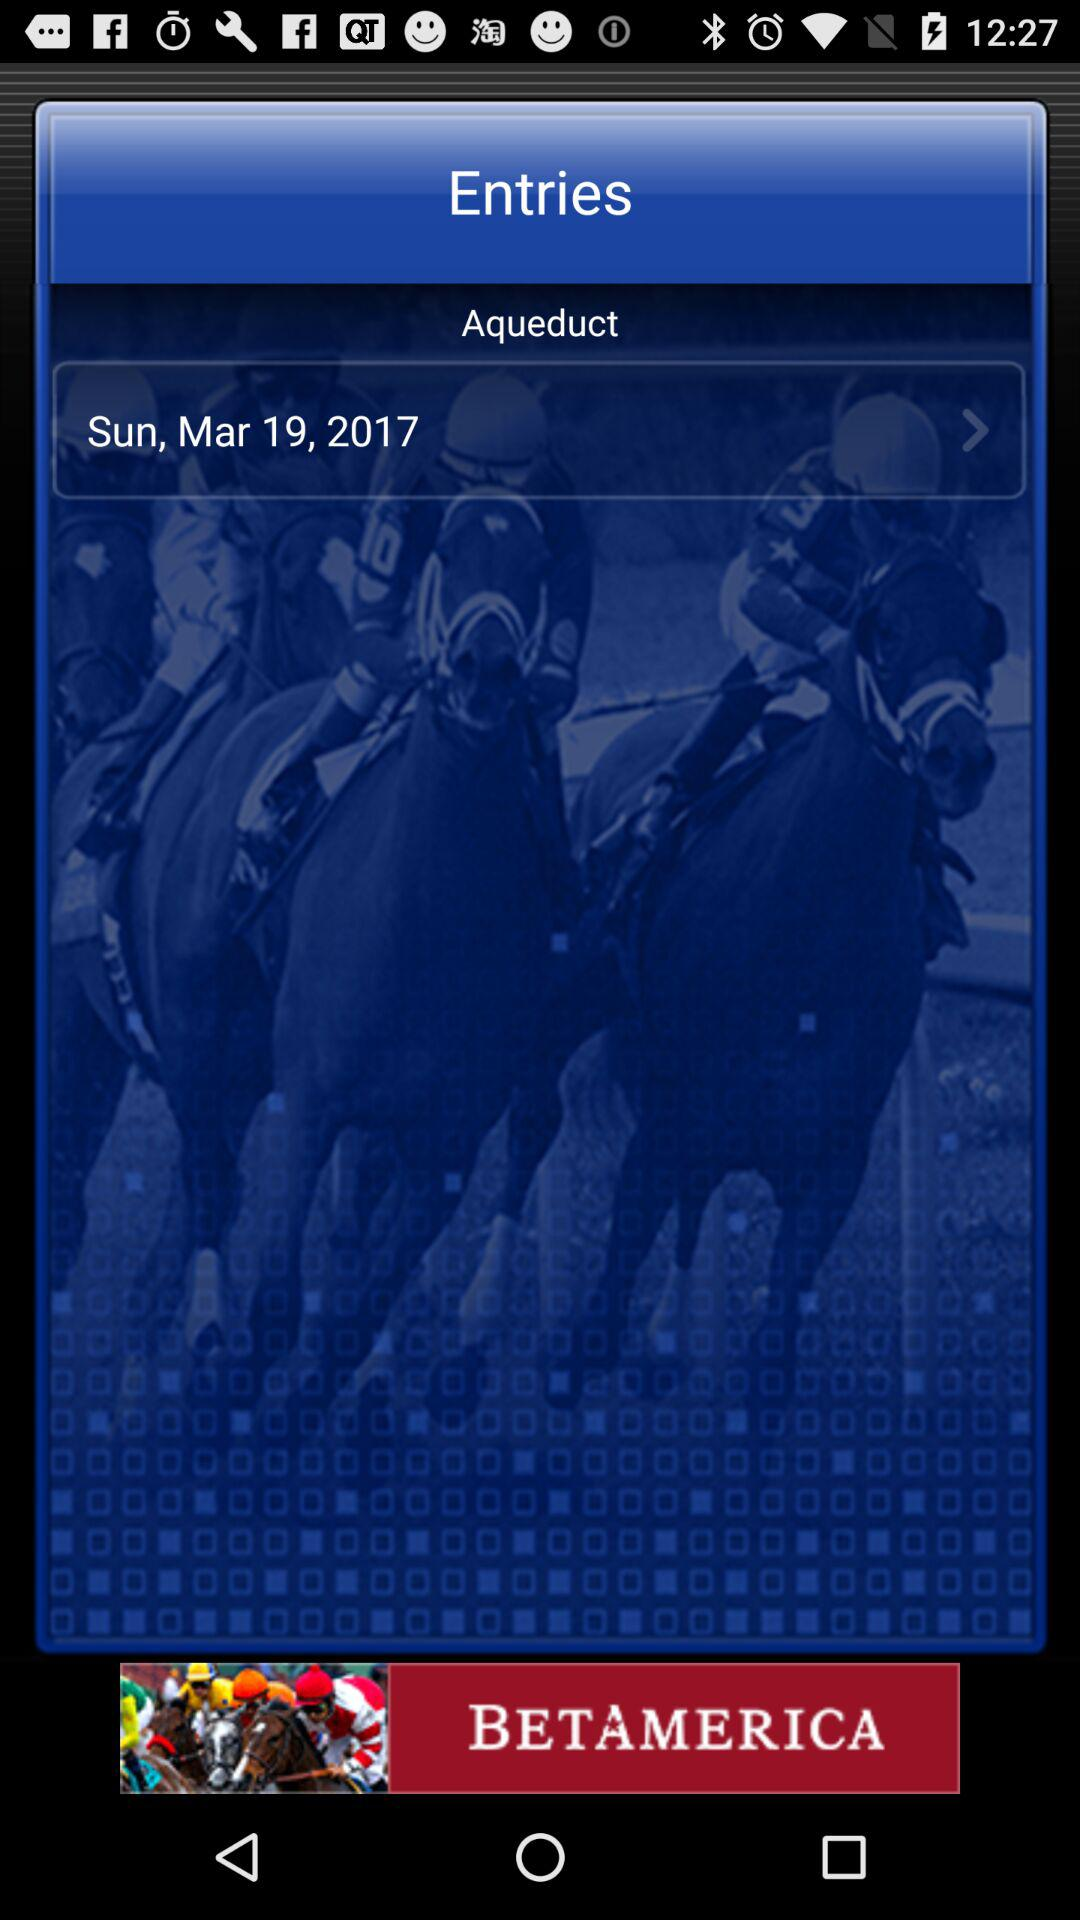What date is selected? The selected is March 19, 2017. 